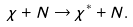<formula> <loc_0><loc_0><loc_500><loc_500>\chi + N \rightarrow \chi ^ { \ast } + N .</formula> 